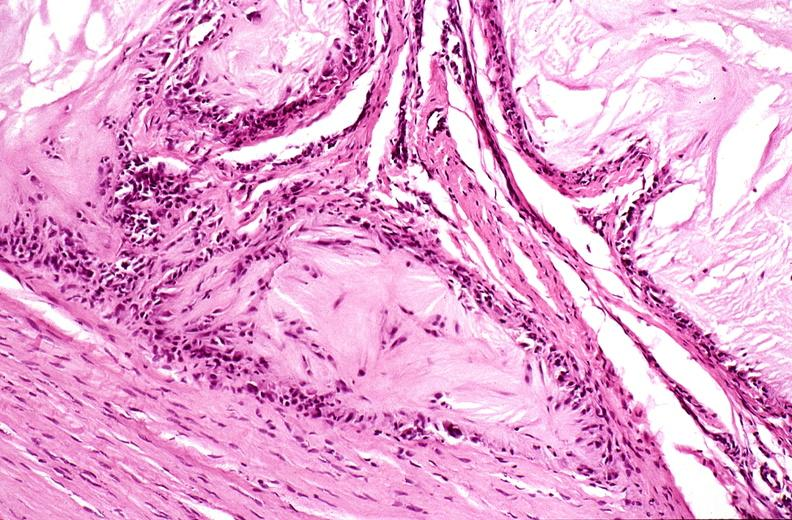what does this image show?
Answer the question using a single word or phrase. Gout 